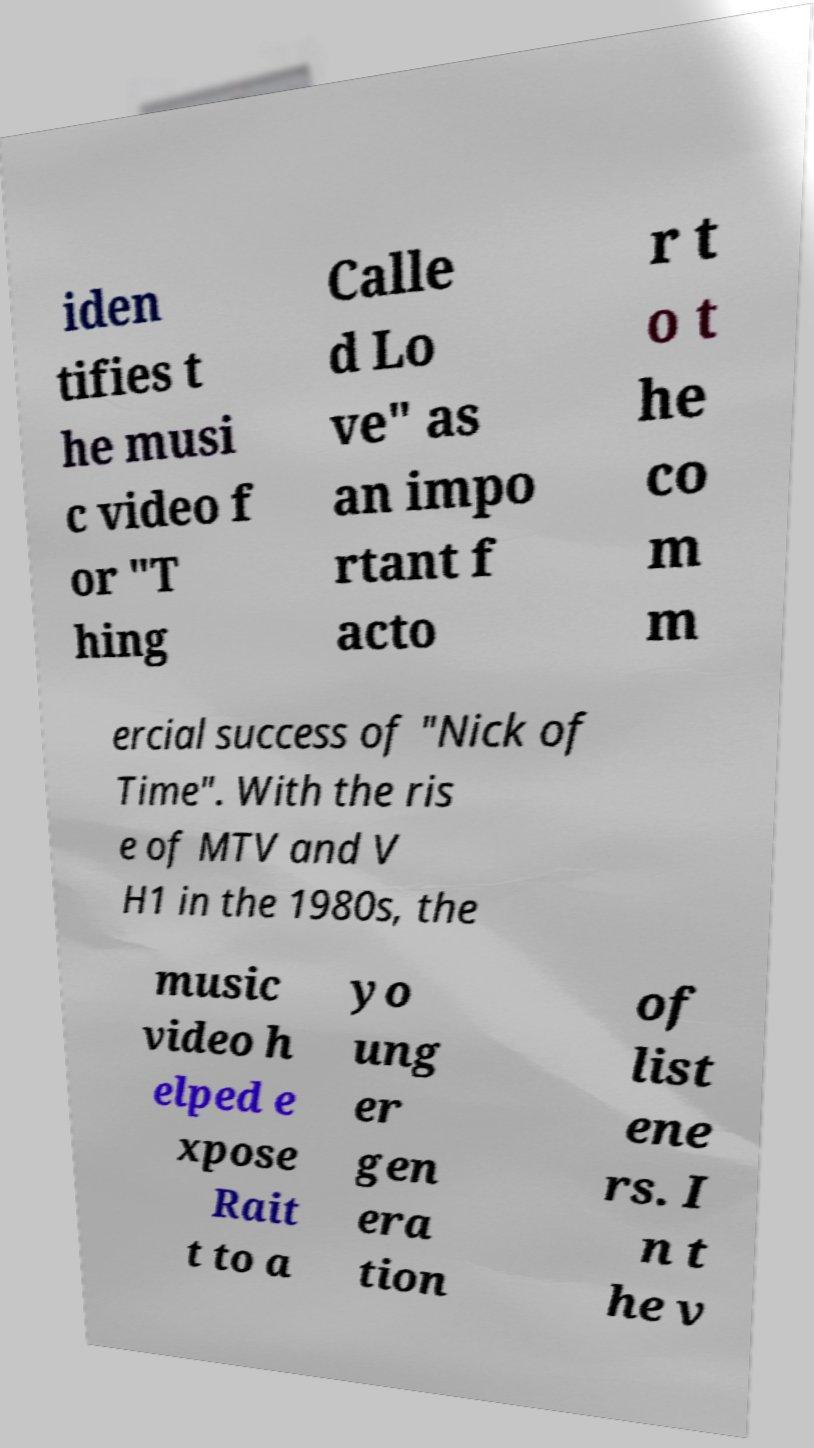Can you read and provide the text displayed in the image?This photo seems to have some interesting text. Can you extract and type it out for me? iden tifies t he musi c video f or "T hing Calle d Lo ve" as an impo rtant f acto r t o t he co m m ercial success of "Nick of Time". With the ris e of MTV and V H1 in the 1980s, the music video h elped e xpose Rait t to a yo ung er gen era tion of list ene rs. I n t he v 